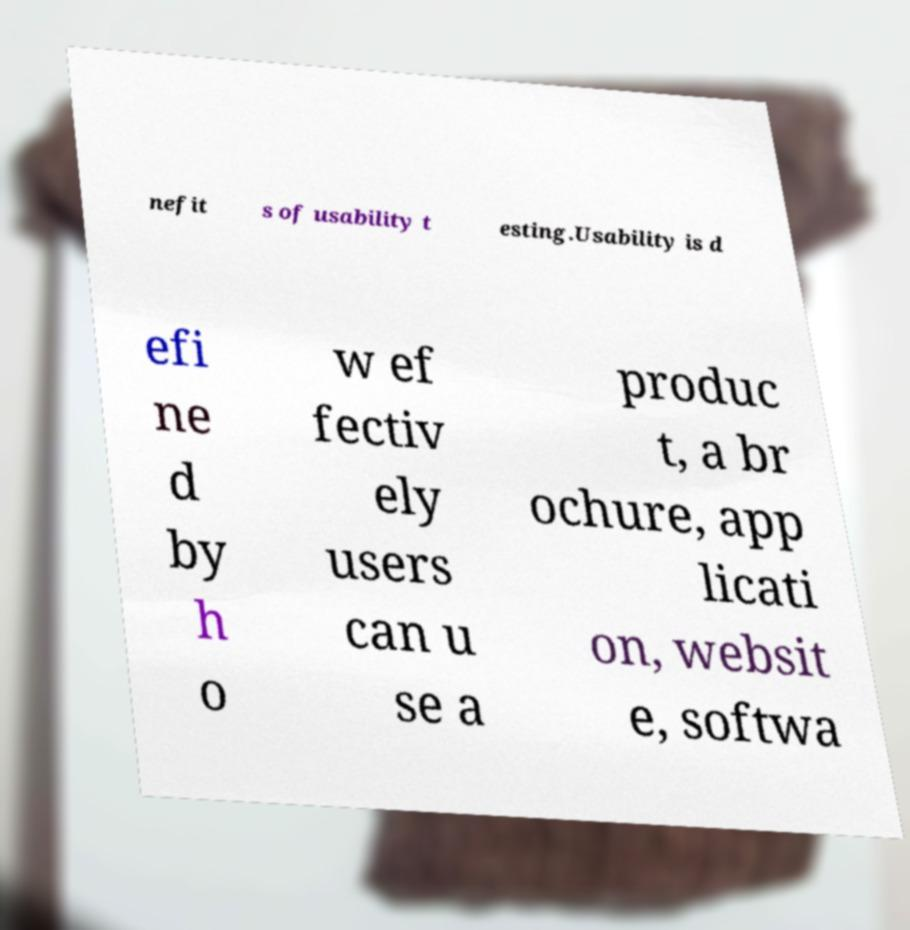Could you extract and type out the text from this image? nefit s of usability t esting.Usability is d efi ne d by h o w ef fectiv ely users can u se a produc t, a br ochure, app licati on, websit e, softwa 